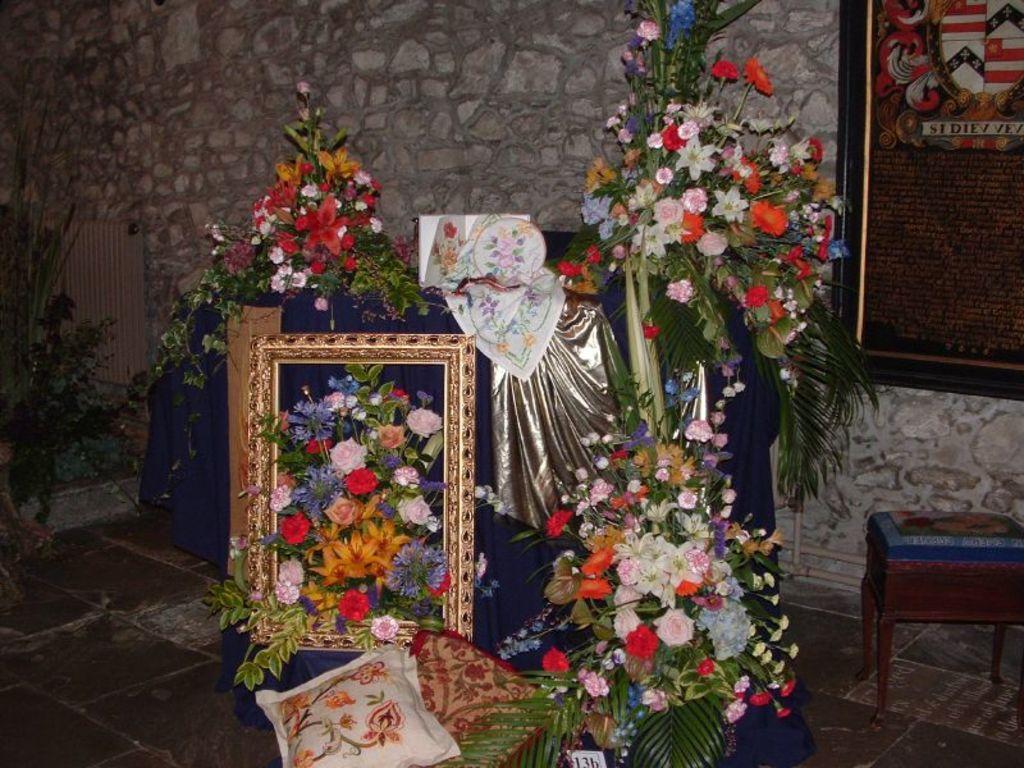Could you give a brief overview of what you see in this image? In this image I can see the flower bouquets which are colorful. To the side I can see the pillows and the stool. I can also see the blue and silver cloth. In the background I can see the board to the wall. 